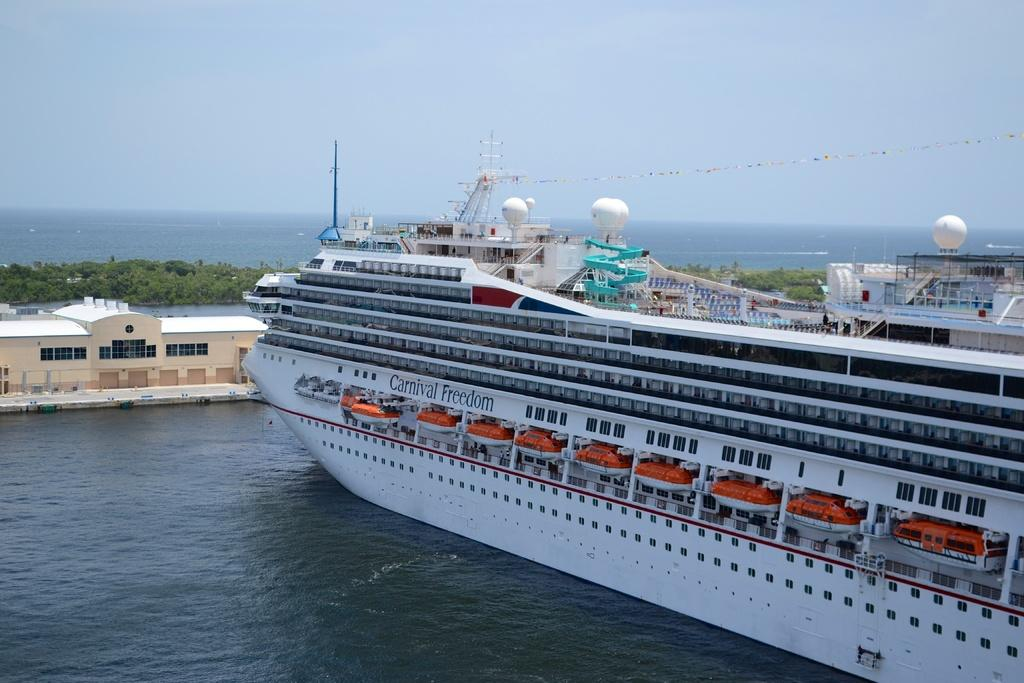What is located in the water in the image? There are ships in the water in the image. What can be seen in the background of the image? There are trees in the background of the image. What object is visible in the image that might be used for tying or securing? There is a rope visible in the image. What is visible at the top of the image? The sky is visible at the top of the image. What type of paint is being used to color the spade in the image? There is no spade or paint present in the image. How is the scale being used in the image? There is no scale present in the image. 